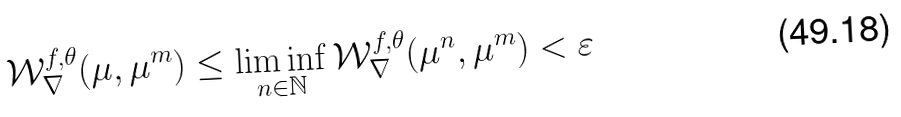<formula> <loc_0><loc_0><loc_500><loc_500>\mathcal { W } _ { \nabla } ^ { f , \theta } ( \mu , \mu ^ { m } ) \leq \liminf _ { n \in \mathbb { N } } \mathcal { W } _ { \nabla } ^ { f , \theta } ( \mu ^ { n } , \mu ^ { m } ) < \varepsilon</formula> 